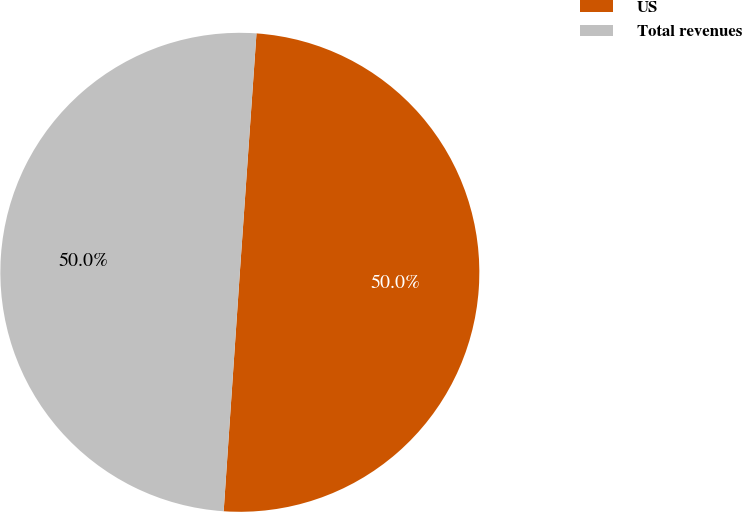<chart> <loc_0><loc_0><loc_500><loc_500><pie_chart><fcel>US<fcel>Total revenues<nl><fcel>49.97%<fcel>50.03%<nl></chart> 